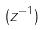Convert formula to latex. <formula><loc_0><loc_0><loc_500><loc_500>( z ^ { - 1 } )</formula> 